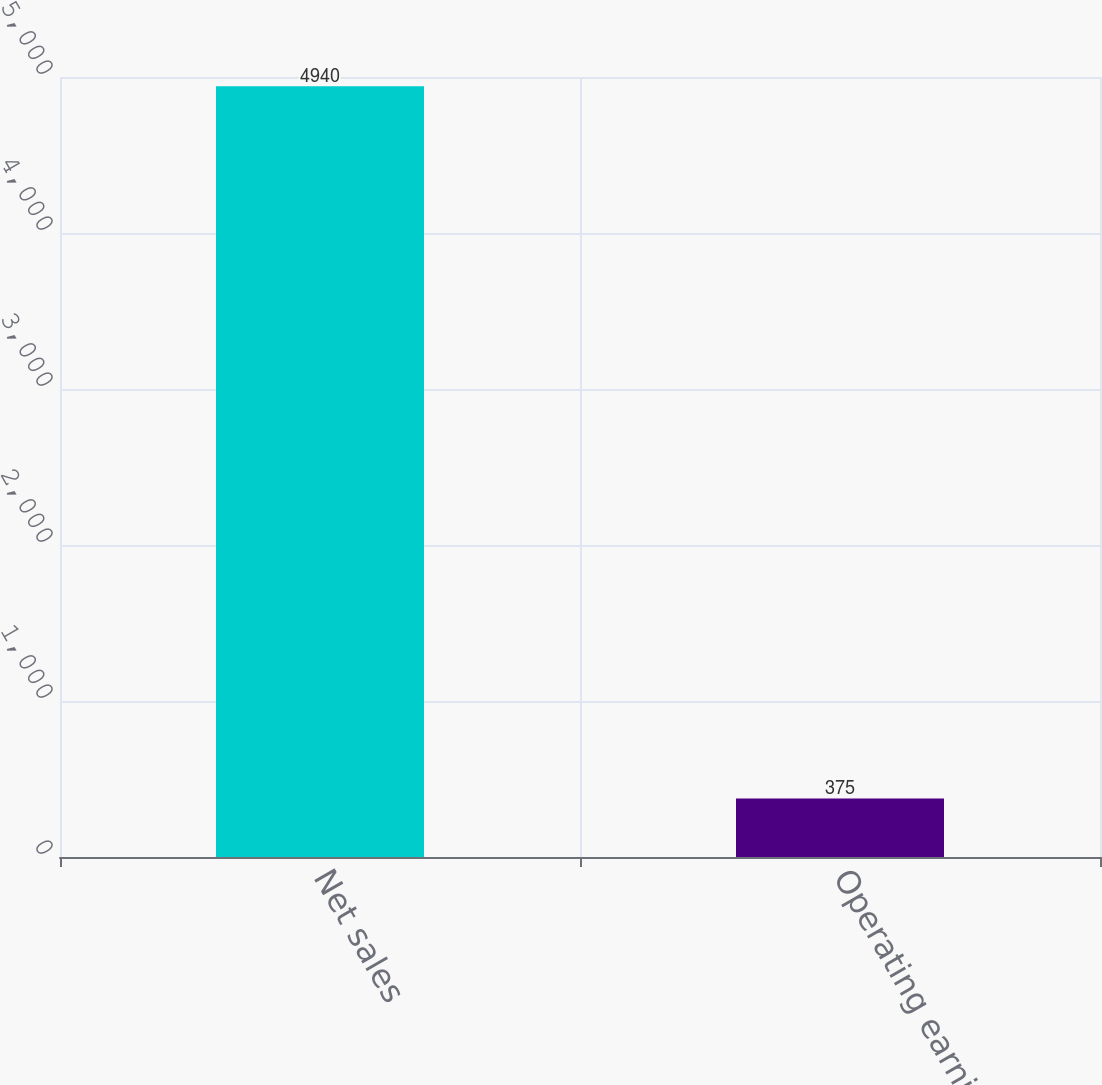<chart> <loc_0><loc_0><loc_500><loc_500><bar_chart><fcel>Net sales<fcel>Operating earnings<nl><fcel>4940<fcel>375<nl></chart> 